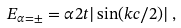Convert formula to latex. <formula><loc_0><loc_0><loc_500><loc_500>E _ { \alpha = \pm } = \alpha 2 t | \sin ( k c / 2 ) | \, ,</formula> 